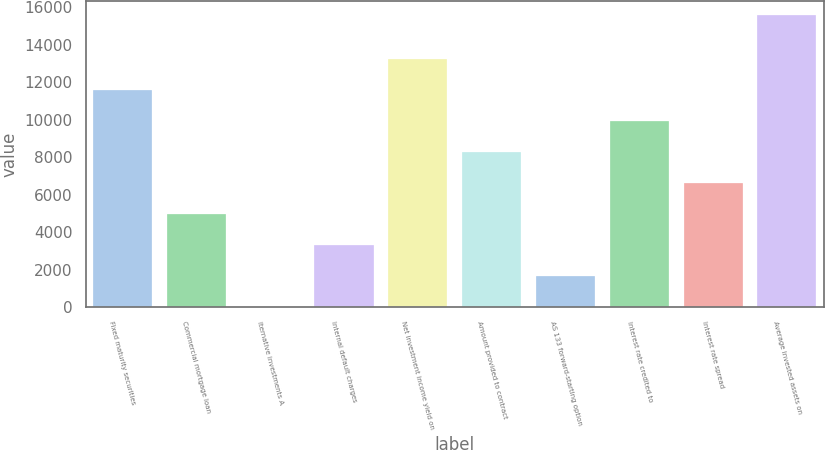Convert chart to OTSL. <chart><loc_0><loc_0><loc_500><loc_500><bar_chart><fcel>Fixed maturity securities<fcel>Commercial mortgage loan<fcel>lternative investments A<fcel>Internal default charges<fcel>Net investment income yield on<fcel>Amount provided to contract<fcel>AS 133 forward-starting option<fcel>Interest rate credited to<fcel>Interest rate spread<fcel>Average invested assets on<nl><fcel>11567.5<fcel>4957.52<fcel>0.02<fcel>3305.02<fcel>13220<fcel>8262.52<fcel>1652.52<fcel>9915.02<fcel>6610.02<fcel>15551<nl></chart> 